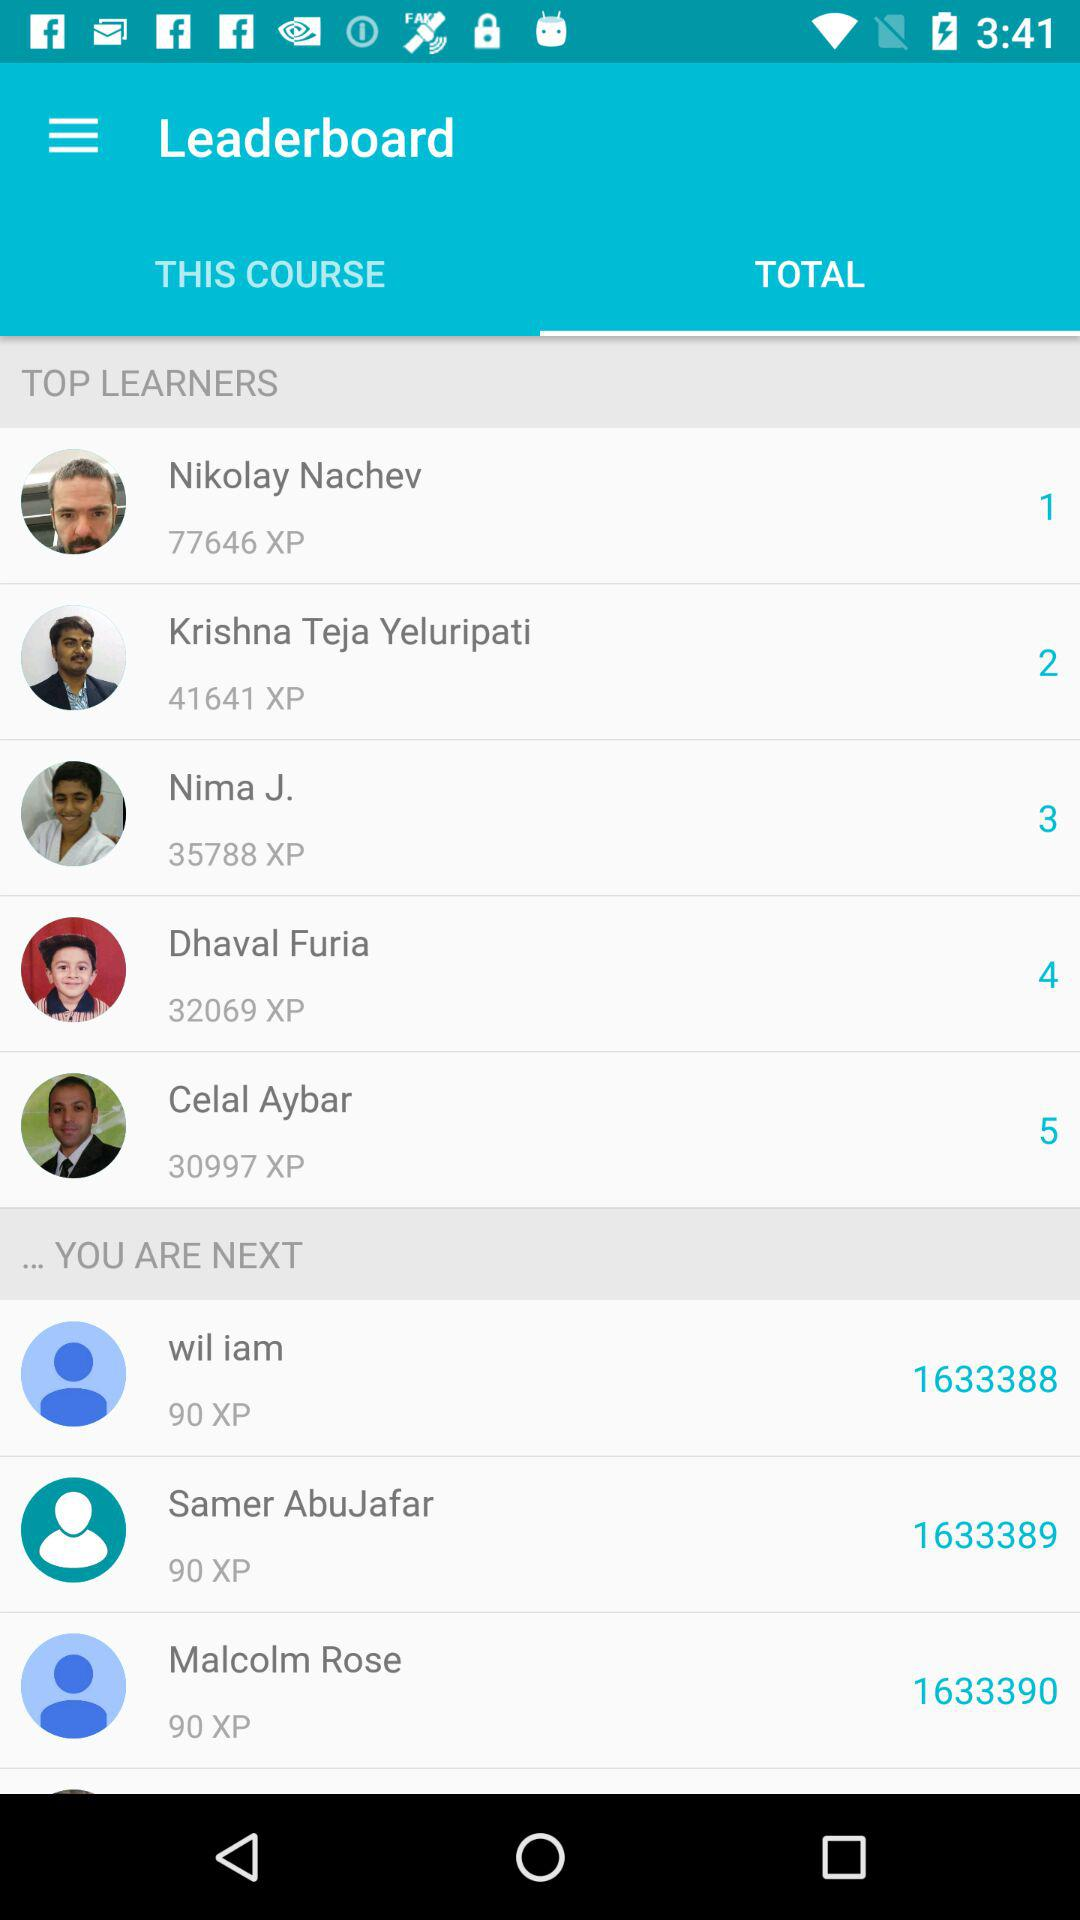How many XP does the person in 5th place have?
Answer the question using a single word or phrase. 30997 